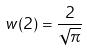<formula> <loc_0><loc_0><loc_500><loc_500>w ( 2 ) = \frac { 2 } { \sqrt { \pi } }</formula> 